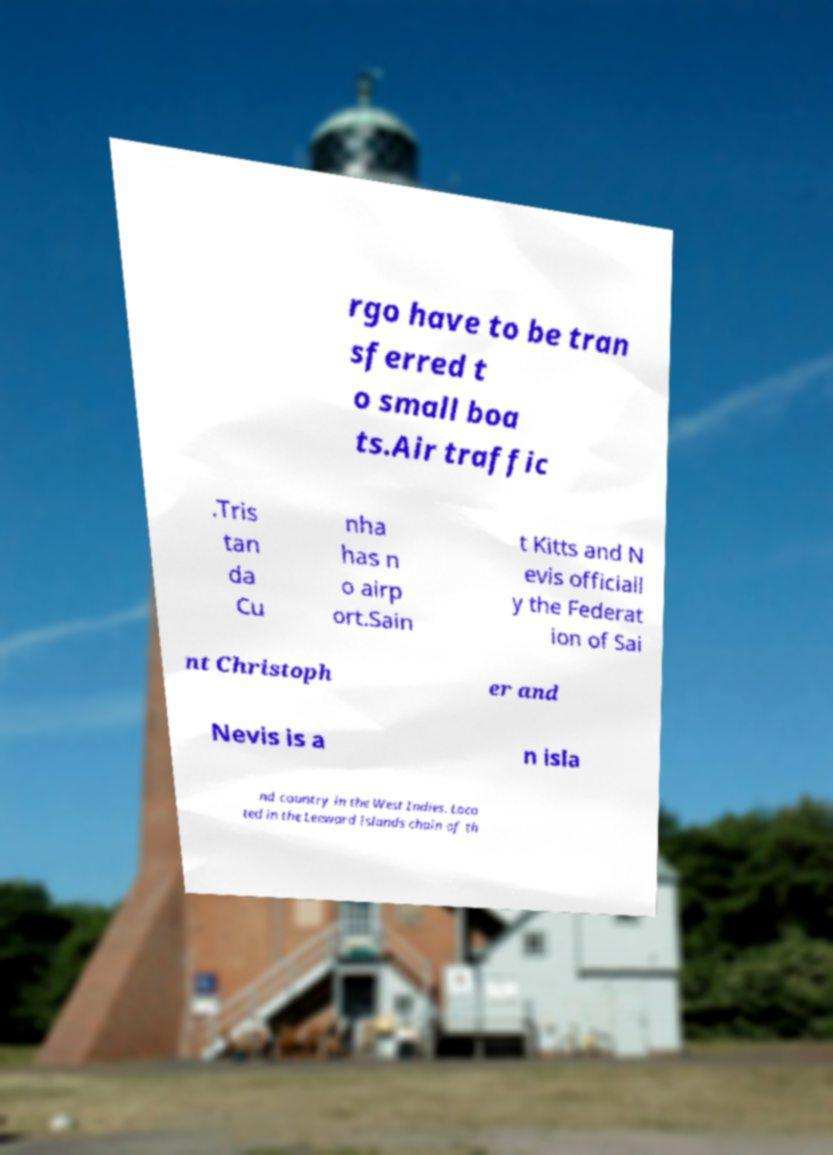Could you assist in decoding the text presented in this image and type it out clearly? rgo have to be tran sferred t o small boa ts.Air traffic .Tris tan da Cu nha has n o airp ort.Sain t Kitts and N evis officiall y the Federat ion of Sai nt Christoph er and Nevis is a n isla nd country in the West Indies. Loca ted in the Leeward Islands chain of th 